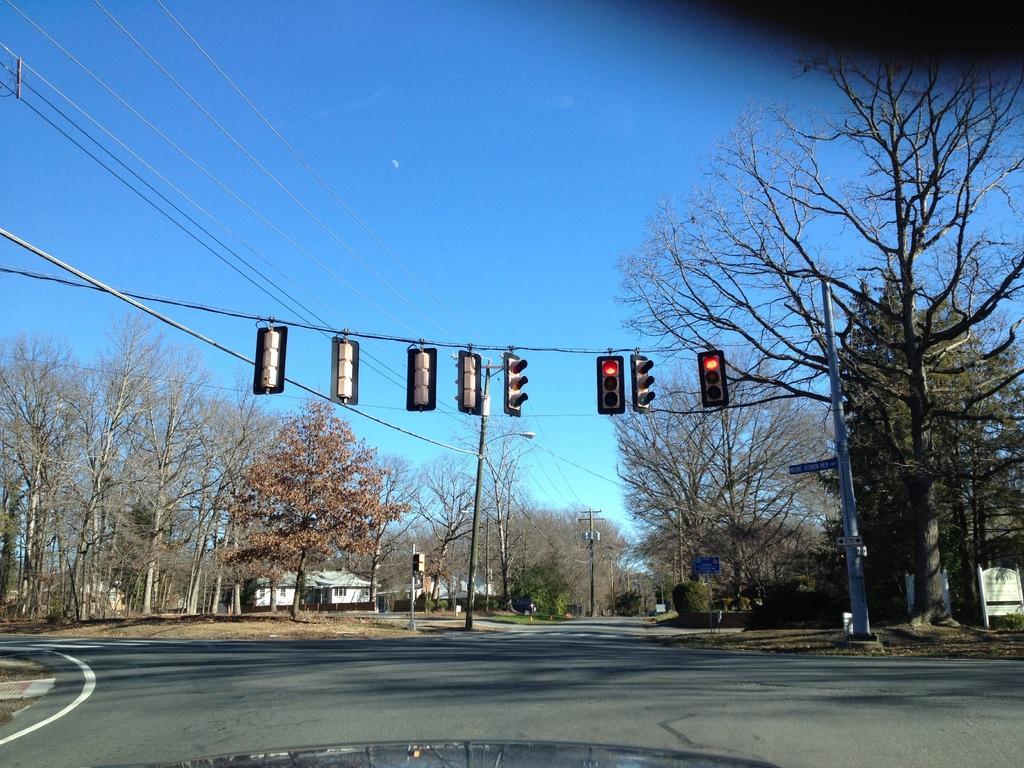Can you describe this image briefly? At the bottom of the image there is road. There is a pole with wire and there are few traffic signals hanging on the wire. And in the background there are trees, electric poles with wires and street lights. And also there are few houses. At the top of the image there is sky. 